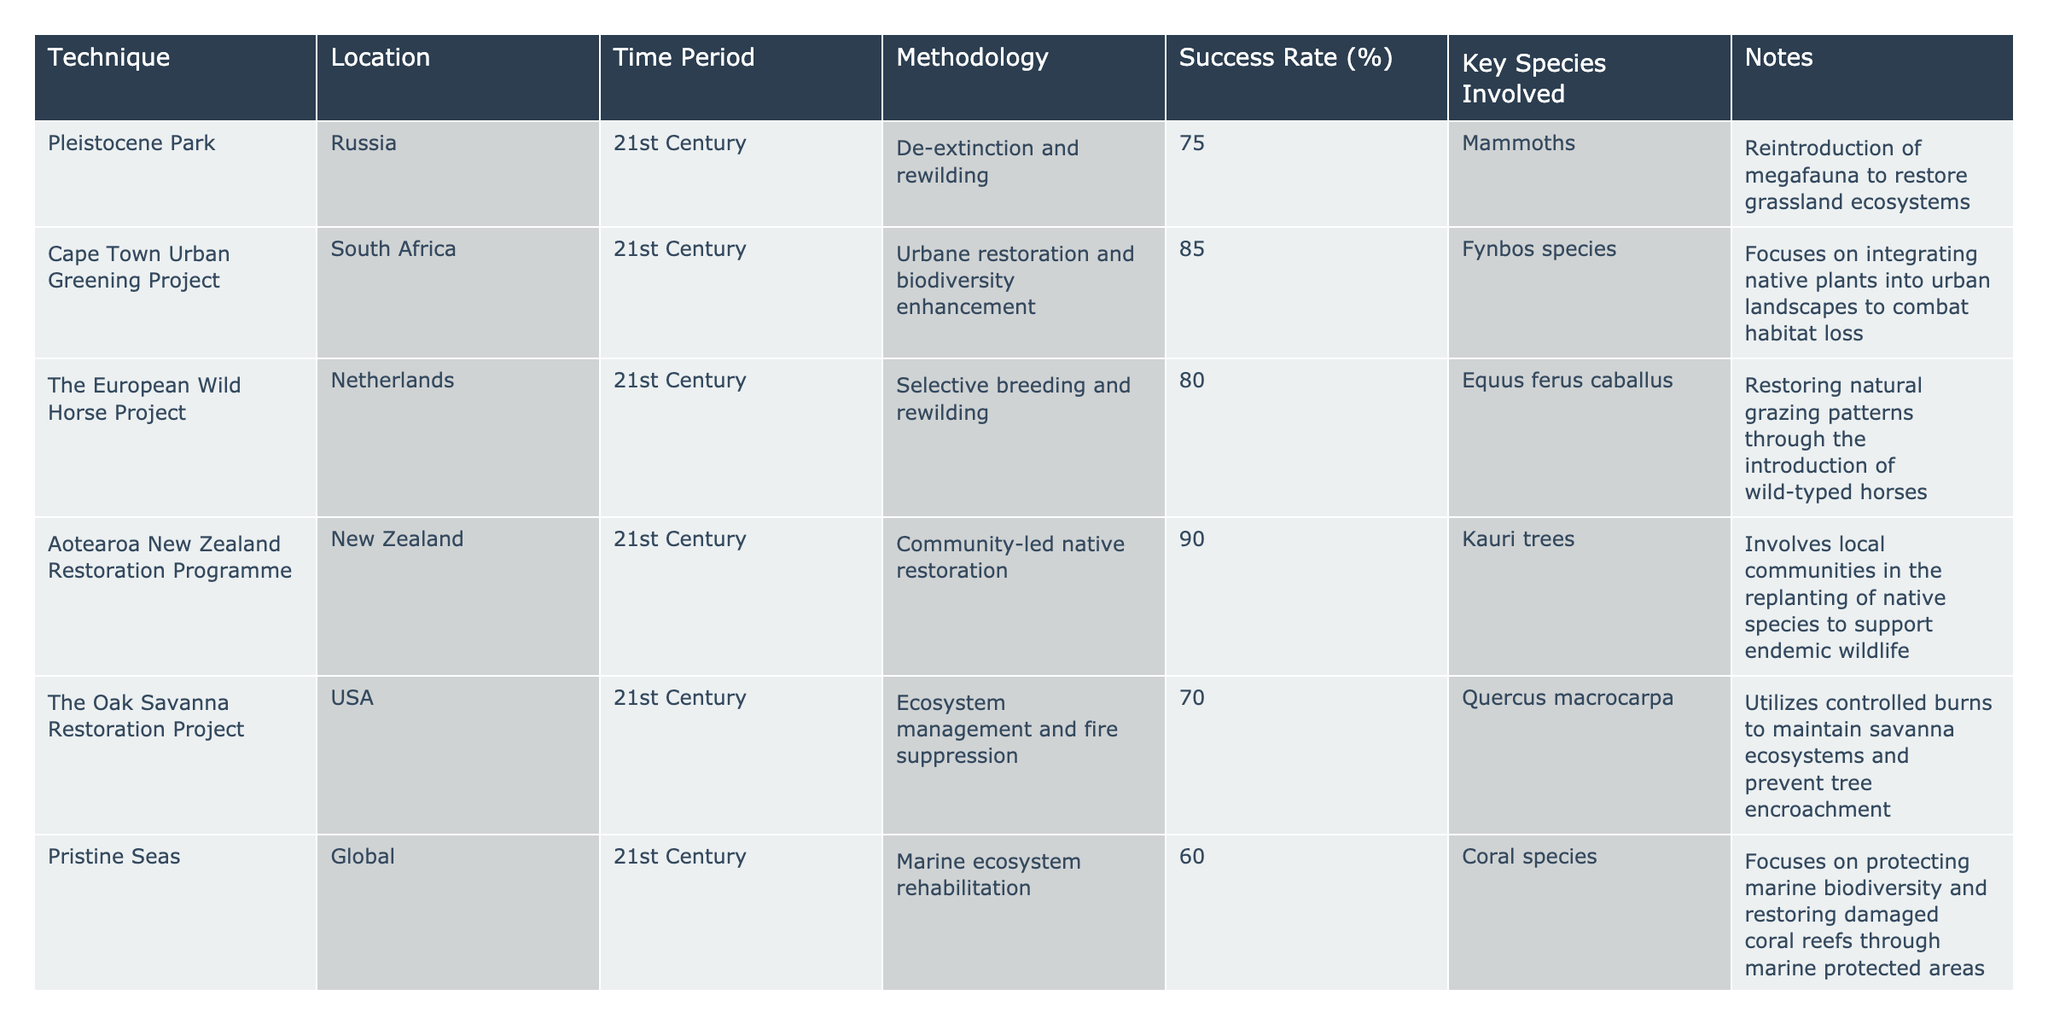What is the success rate of the Aotearoa New Zealand Restoration Programme? The success rate is stated in the "Success Rate (%)" column for this project, which is listed as 90%.
Answer: 90% Which technique has the highest success rate and what is that rate? The "Success Rate (%)" column shows Aotearoa New Zealand Restoration Programme with the highest rate at 90%.
Answer: Aotearoa New Zealand Restoration Programme, 90% Is the methodology used in the Cape Town Urban Greening Project focused on marine ecosystems? The methodology in the "Methodology" column specifically mentions urbane restoration, which does not pertain to marine ecosystems.
Answer: No What is the average success rate of the ecosystem restoration techniques listed in the table? To find the average: (75 + 85 + 80 + 90 + 70 + 60 + 78 + 72 + 68) = 78.33, dividing by the number of techniques (9), we get approximately 78.33.
Answer: 78.33 How many techniques involve direct community engagement in their methodology? The Aotearoa New Zealand Restoration Programme is the only one that mentions community-led native restoration, hence there is 1 technique.
Answer: 1 Which location focuses on integrating native plants into urban landscapes? The Cape Town Urban Greening Project is designed for integrating native species into urban landscapes, as noted in the "Location" and "Methodology" columns.
Answer: Cape Town Urban Greening Project Are there any techniques listed that involve the reintroduction of megafauna? The Pleistocene Park technique focuses on reintroducing mammoths, which classifies as megafauna.
Answer: Yes What percentage of techniques mentioned have a success rate above 75%? The count of techniques with a success rate above 75% includes 5 out of 9 (Aotearoa New Zealand Restoration Programme, Cape Town Urban Greening Project, The European Wild Horse Project, Pioneer Forests, The Oak Savanna Restoration Project), resulting in approximately 55.56%.
Answer: Approximately 55.56% Which technique is devoted to marine ecosystem rehabilitation and what is its success rate? The "Pristine Seas" listed for marine ecosystem rehabilitation shows a success rate of 60%.
Answer: Pristine Seas, 60% What are the key species involved in the Murray-Darling Basin Plan? The "Key Species Involved" column indicates that various aquatic species are involved in the Murray-Darling Basin Plan.
Answer: Various aquatic species How many techniques listed are primarily focused on forest restoration? There are 3 techniques aimed at forest restoration: Aotearoa New Zealand Restoration Programme, Pioneer Forests, and The Oak Savanna Restoration Project.
Answer: 3 